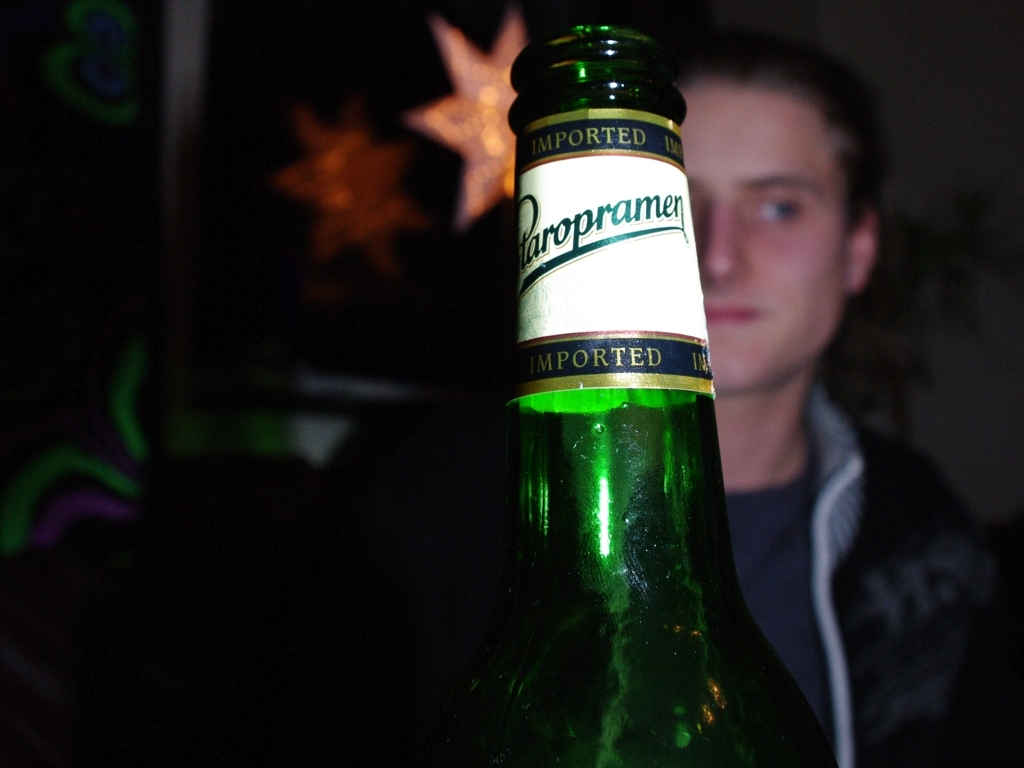What can you infer about the person in the background? Given the soft focus and secondary position in the frame, the person seems to be less important than the bottle in the foreground. Their presence might be intended to humanize the scene or suggest that the beverage is being enjoyed socially. 